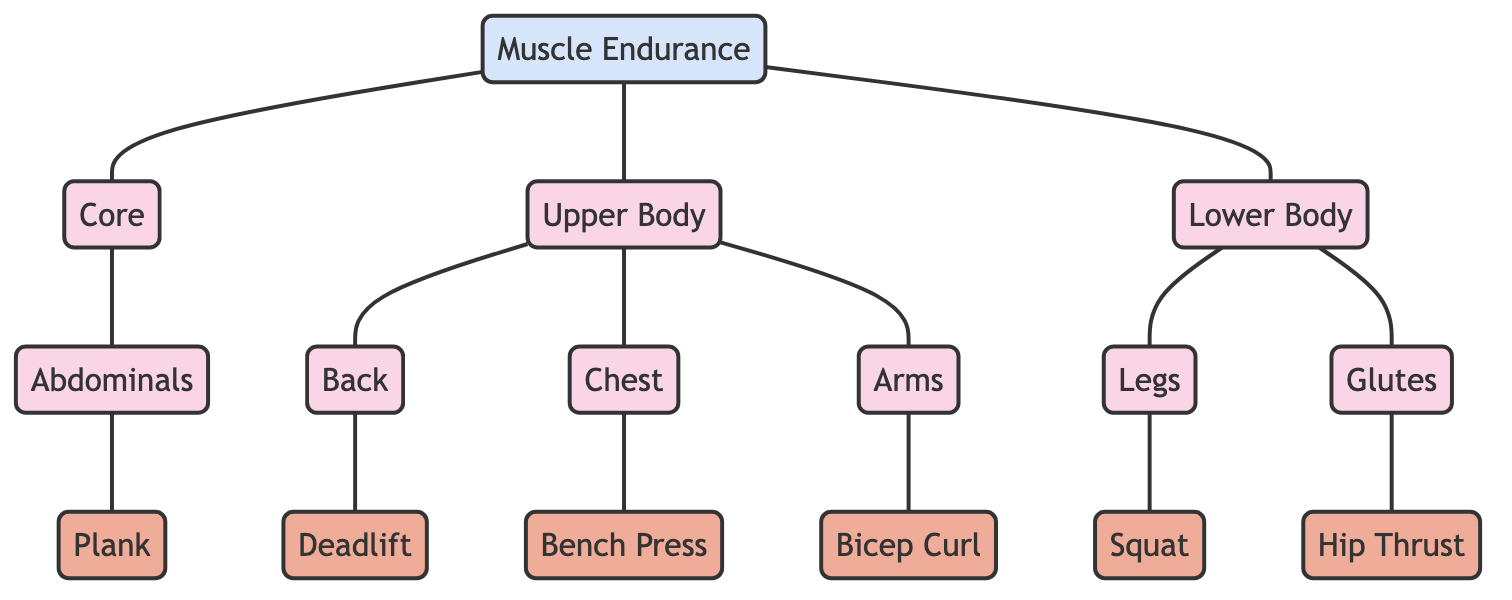What are the three main muscle groups listed in the diagram? The diagram features three main muscle groups: Upper Body, Lower Body, and Core.
Answer: Upper Body, Lower Body, Core How many exercises are associated with the Back muscle group? The Back muscle group is connected to one exercise, Deadlift.
Answer: 1 Which exercise is connected to the Chest muscle group? The Chest muscle group is associated with the exercise Bench Press.
Answer: Bench Press What common relationship do Muscle Endurance and the three main muscle groups share? Muscle Endurance is connected to Upper Body, Lower Body, and Core, showing that it relates to all three muscle groups.
Answer: They are all connected to Muscle Endurance How many nodes are there in total in the diagram? Counting all muscle groups and exercises, there are ten nodes in total: Upper Body, Lower Body, Core, Back, Chest, Arms, Legs, Glutes, Abdominals, and Muscle Endurance.
Answer: 10 Which muscle group has an associated exercise called Hip Thrust? The Glutes muscle group is connected to the exercise Hip Thrust in the diagram.
Answer: Glutes How many edges are there connecting muscle groups to exercises? Six edges connect various muscle groups to their associated exercises: Deadlift, Bench Press, Bicep Curl, Squat, Hip Thrust, and Plank.
Answer: 6 What exercise is connected to the Legs muscle group? The exercise associated with the Legs muscle group in the diagram is Squat.
Answer: Squat Which muscle group has two exercises directly associated with it in the diagram? The Upper Body muscle group is connected to two exercises: Bench Press and Bicep Curl.
Answer: Upper Body 